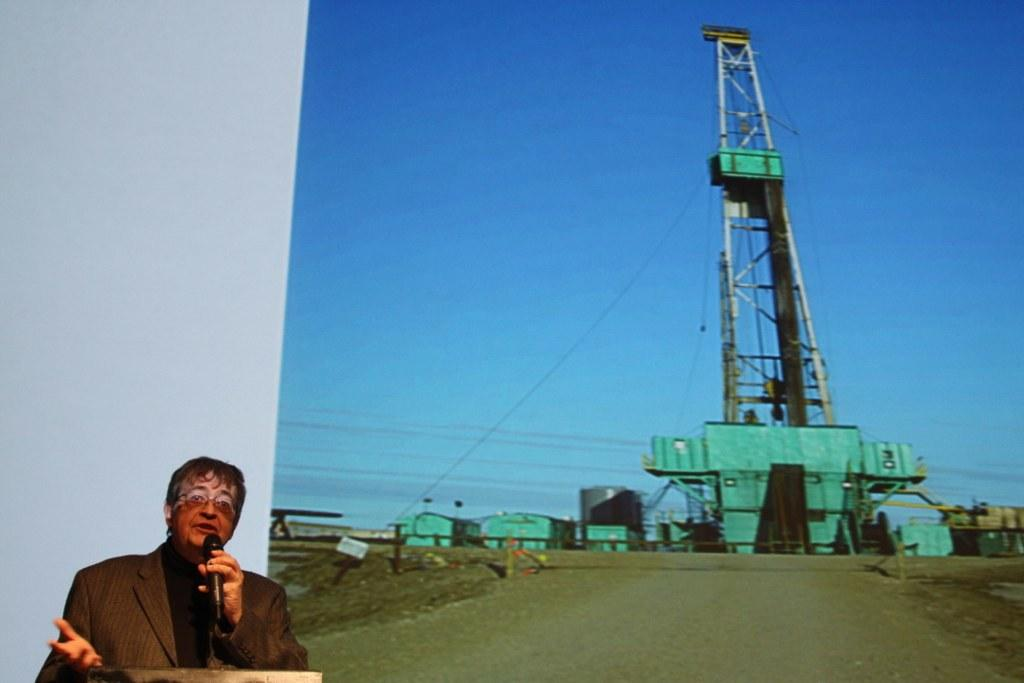What is the man doing in the image? The man is standing on the left side of the image and holding a mic in his hand. What is located behind the man? There is a screen behind the man. What images are displayed on the screen? The screen displays an image of a machine and an image of the sky. What type of canvas is the man painting in the image? There is no canvas present in the image, and the man is not painting. 